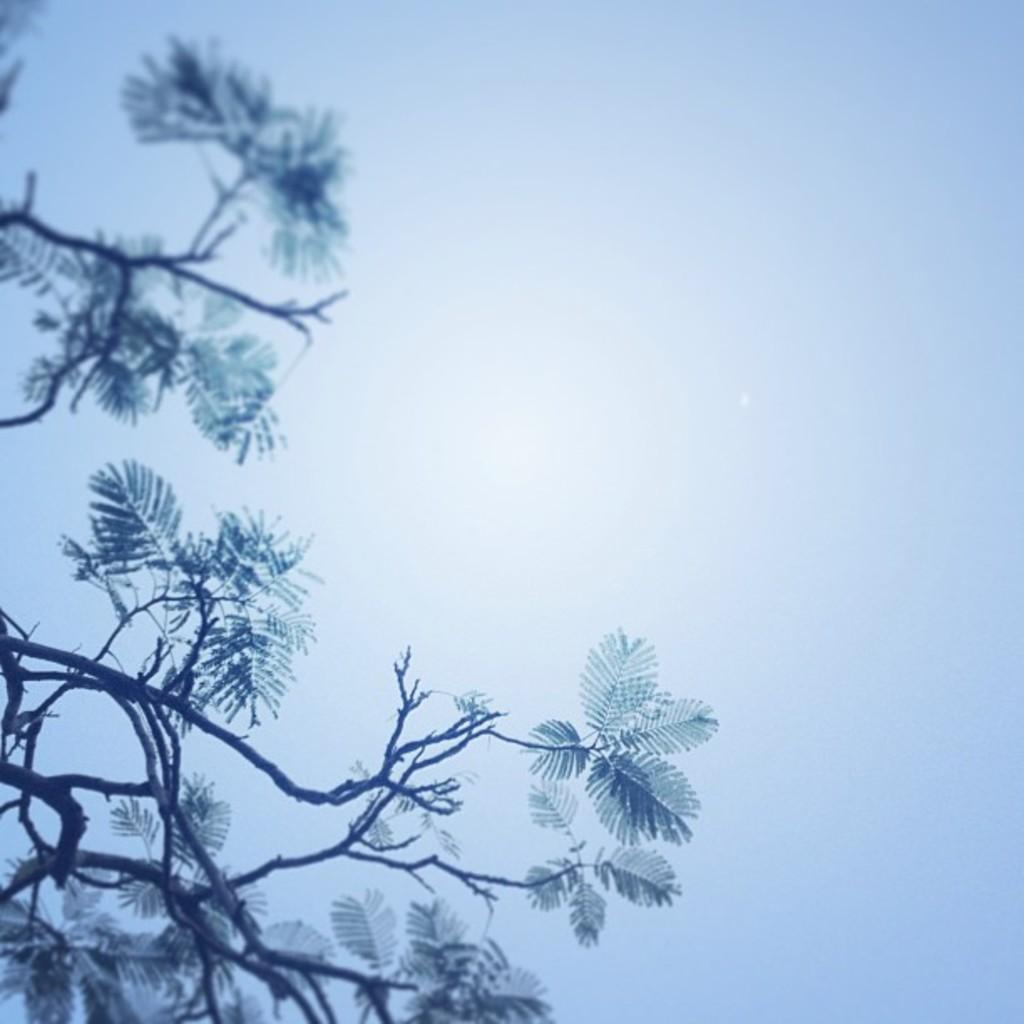Could you give a brief overview of what you see in this image? In this picture we can see leaves, branches and in the background we can see the sky. 